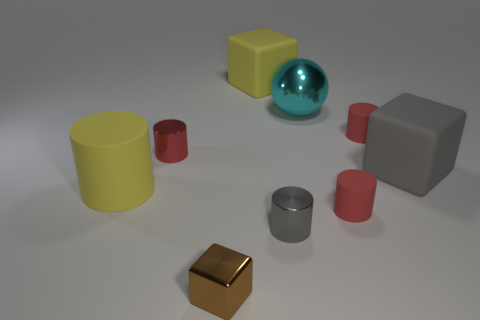Subtract all blue spheres. How many red cylinders are left? 3 Subtract all gray cylinders. How many cylinders are left? 4 Subtract all tiny red shiny cylinders. How many cylinders are left? 4 Subtract 1 cylinders. How many cylinders are left? 4 Subtract all green cylinders. Subtract all red balls. How many cylinders are left? 5 Add 1 big red metallic cubes. How many objects exist? 10 Subtract all spheres. How many objects are left? 8 Subtract all red cylinders. Subtract all large yellow balls. How many objects are left? 6 Add 2 big cyan metal things. How many big cyan metal things are left? 3 Add 5 metal balls. How many metal balls exist? 6 